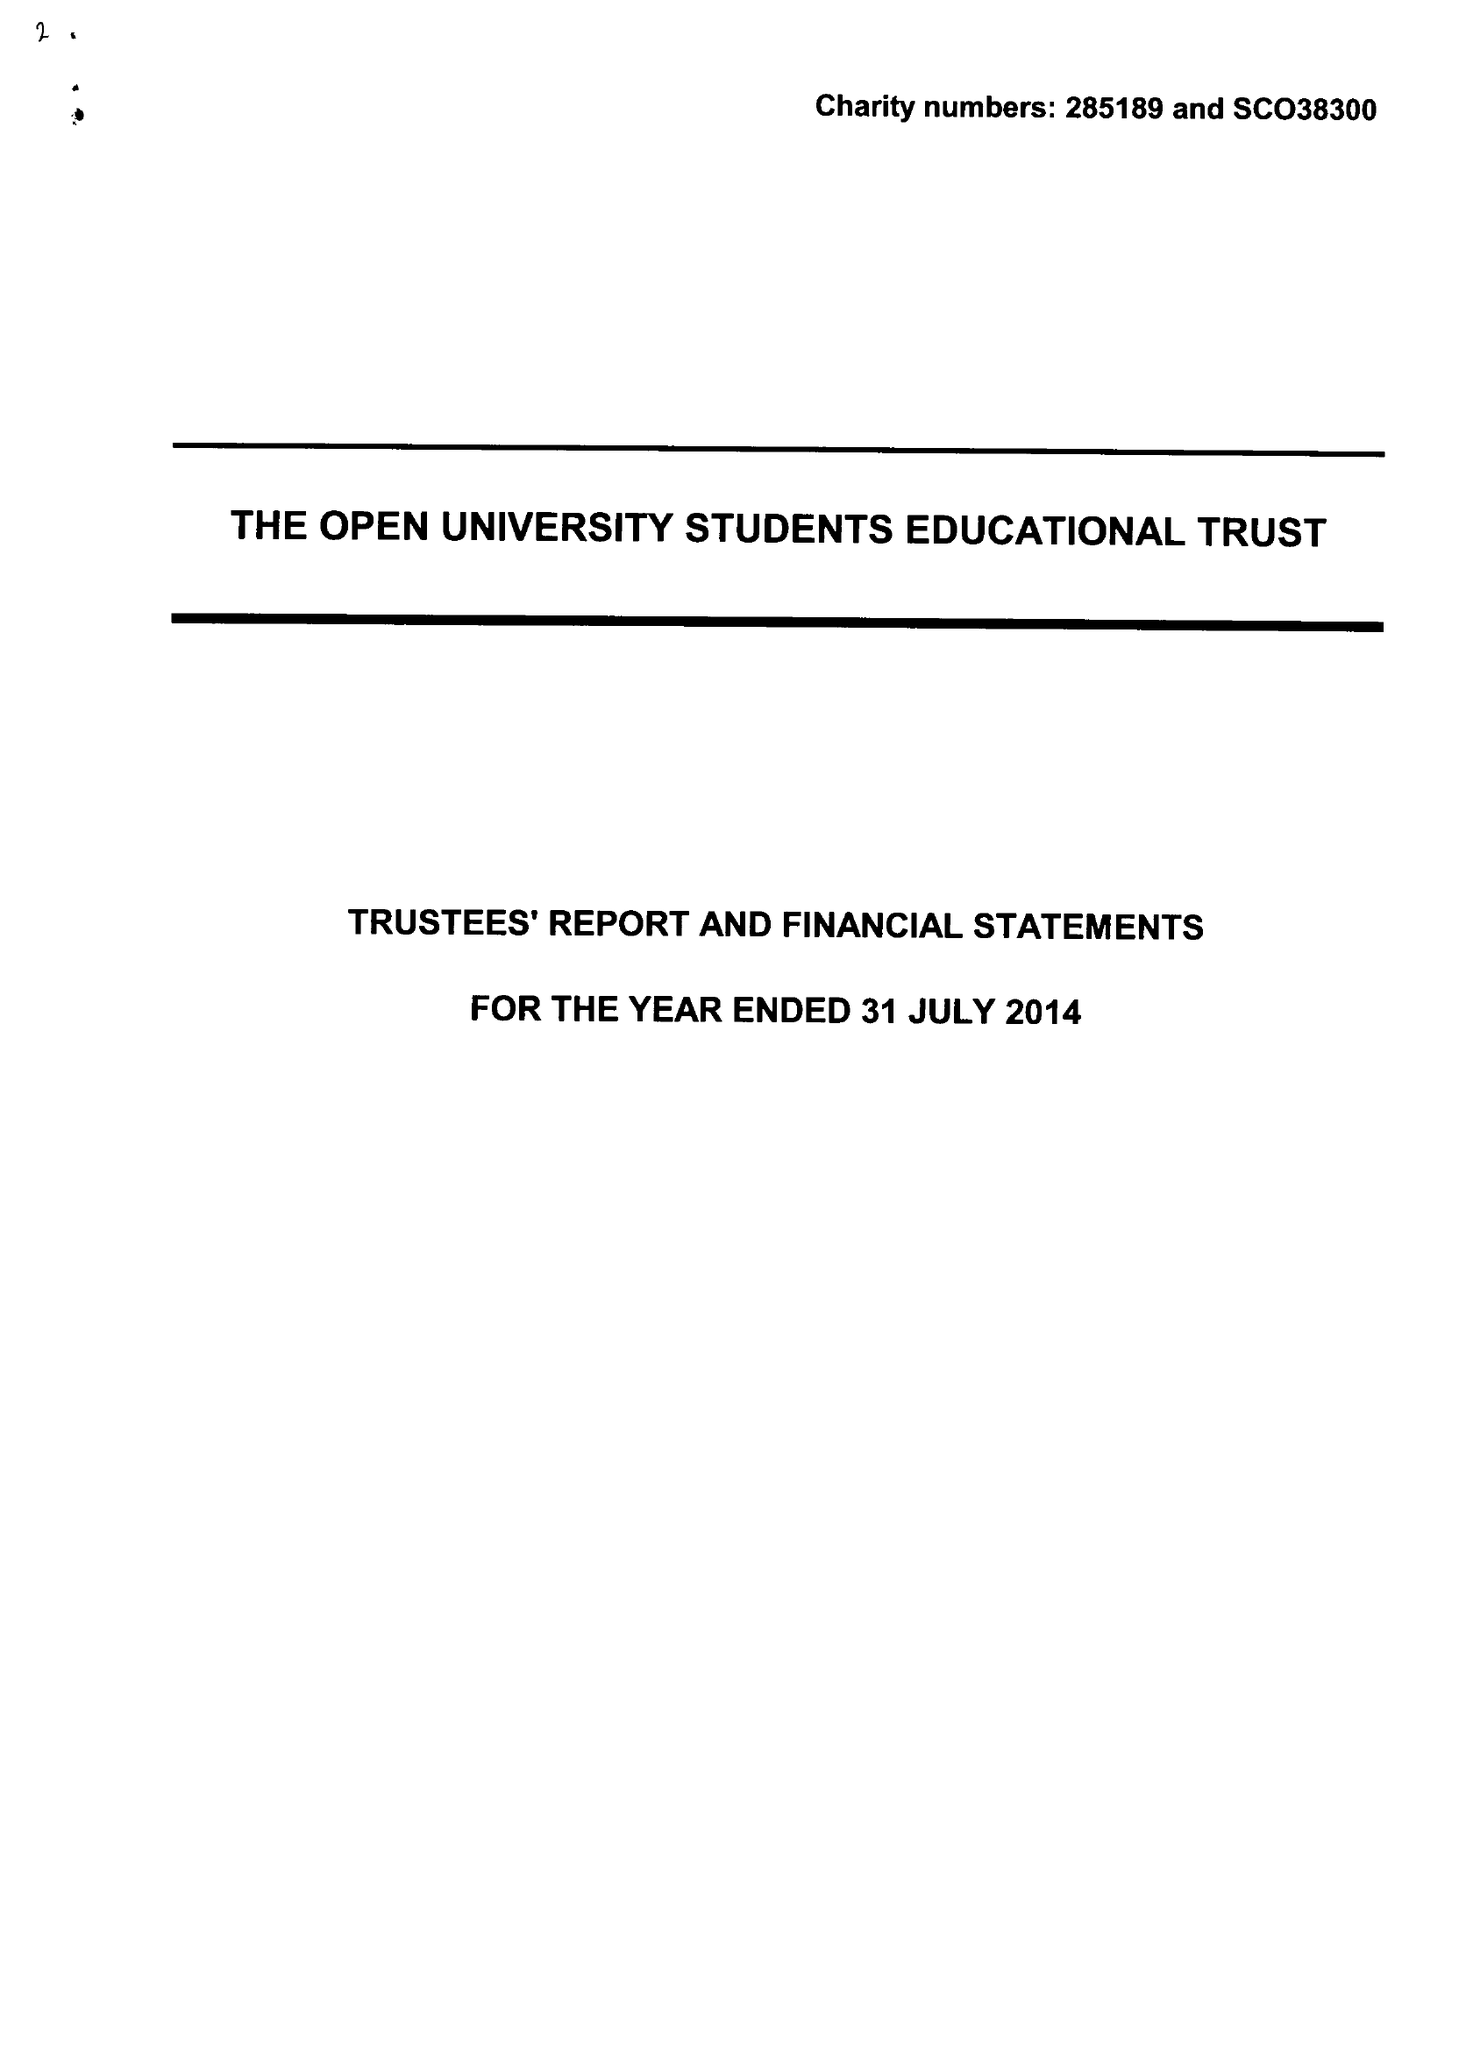What is the value for the report_date?
Answer the question using a single word or phrase. 2014-07-31 